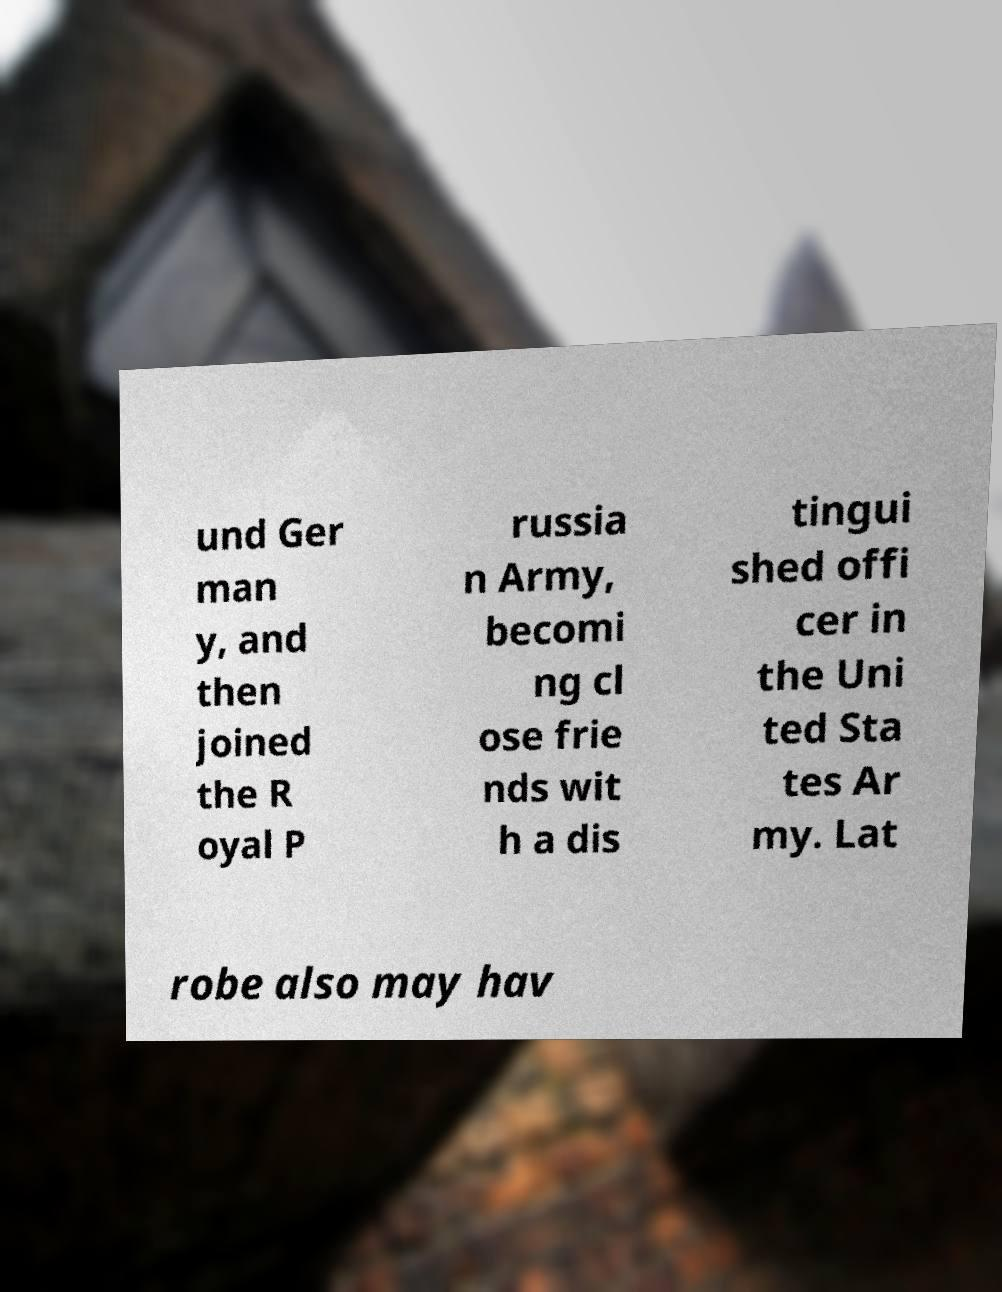Please identify and transcribe the text found in this image. und Ger man y, and then joined the R oyal P russia n Army, becomi ng cl ose frie nds wit h a dis tingui shed offi cer in the Uni ted Sta tes Ar my. Lat robe also may hav 